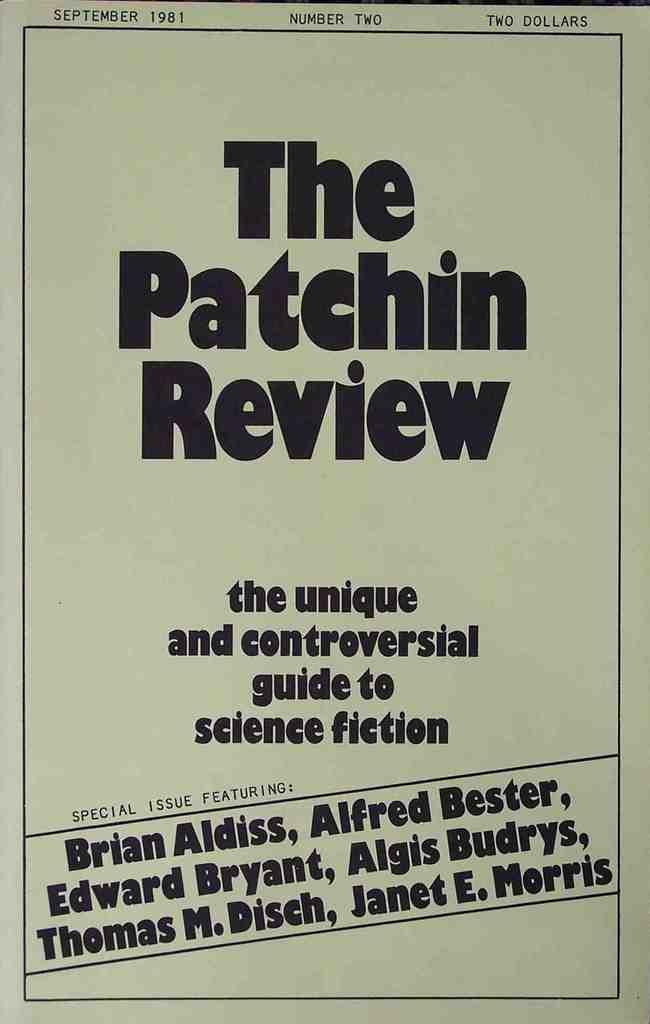Who is the first name listed?
Give a very brief answer. Brian aldiss. What is the last word?
Provide a short and direct response. Morris. 